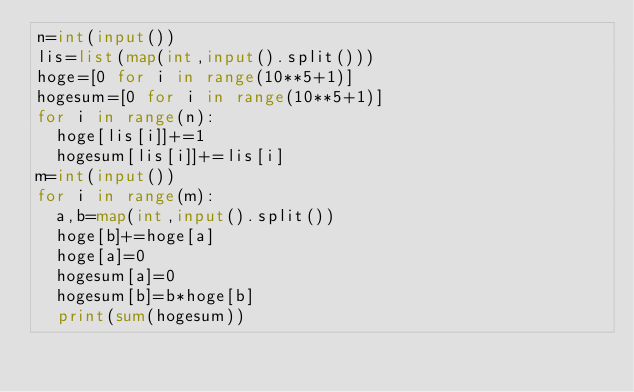<code> <loc_0><loc_0><loc_500><loc_500><_Python_>n=int(input())
lis=list(map(int,input().split()))
hoge=[0 for i in range(10**5+1)]
hogesum=[0 for i in range(10**5+1)]
for i in range(n):
  hoge[lis[i]]+=1
  hogesum[lis[i]]+=lis[i]
m=int(input())
for i in range(m):
  a,b=map(int,input().split())
  hoge[b]+=hoge[a]
  hoge[a]=0
  hogesum[a]=0
  hogesum[b]=b*hoge[b]
  print(sum(hogesum))</code> 